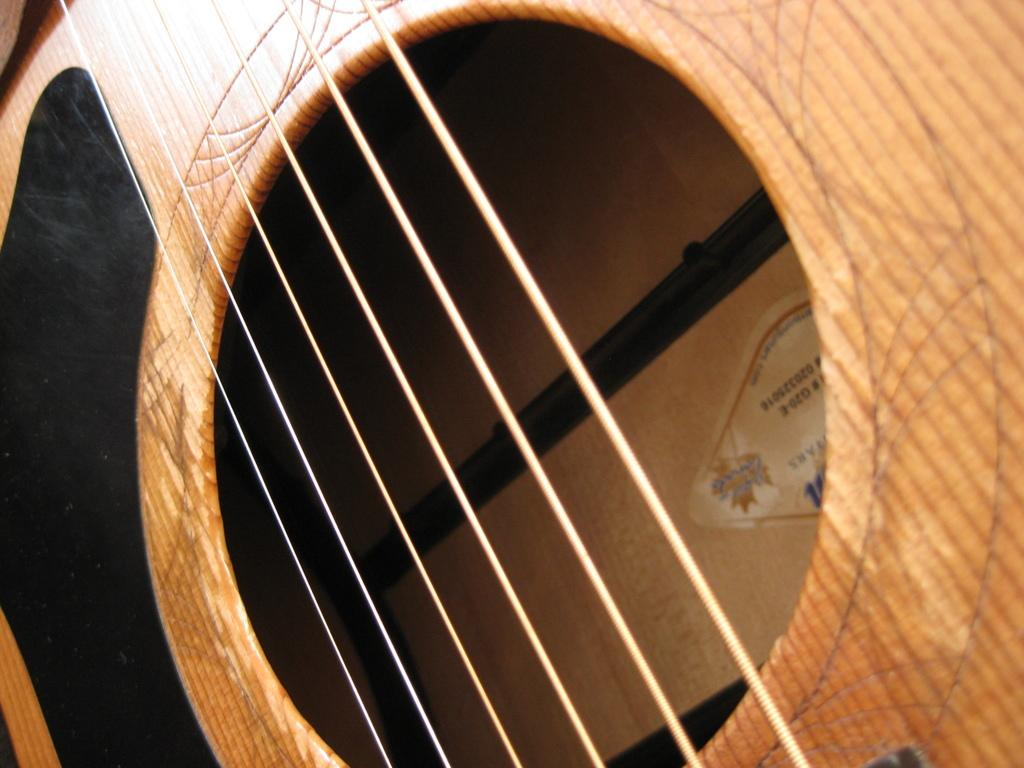What musical instrument is present in the image? There is a guitar in the image. What colors can be seen on the guitar? The guitar has a black and brown color. Did the earthquake cause any damage to the guitar in the image? There is no mention of an earthquake in the image or the provided facts, and therefore no such damage can be observed. What type of knowledge is being shared through the guitar in the image? The image does not depict any knowledge being shared; it simply shows a guitar with a black and brown color. 